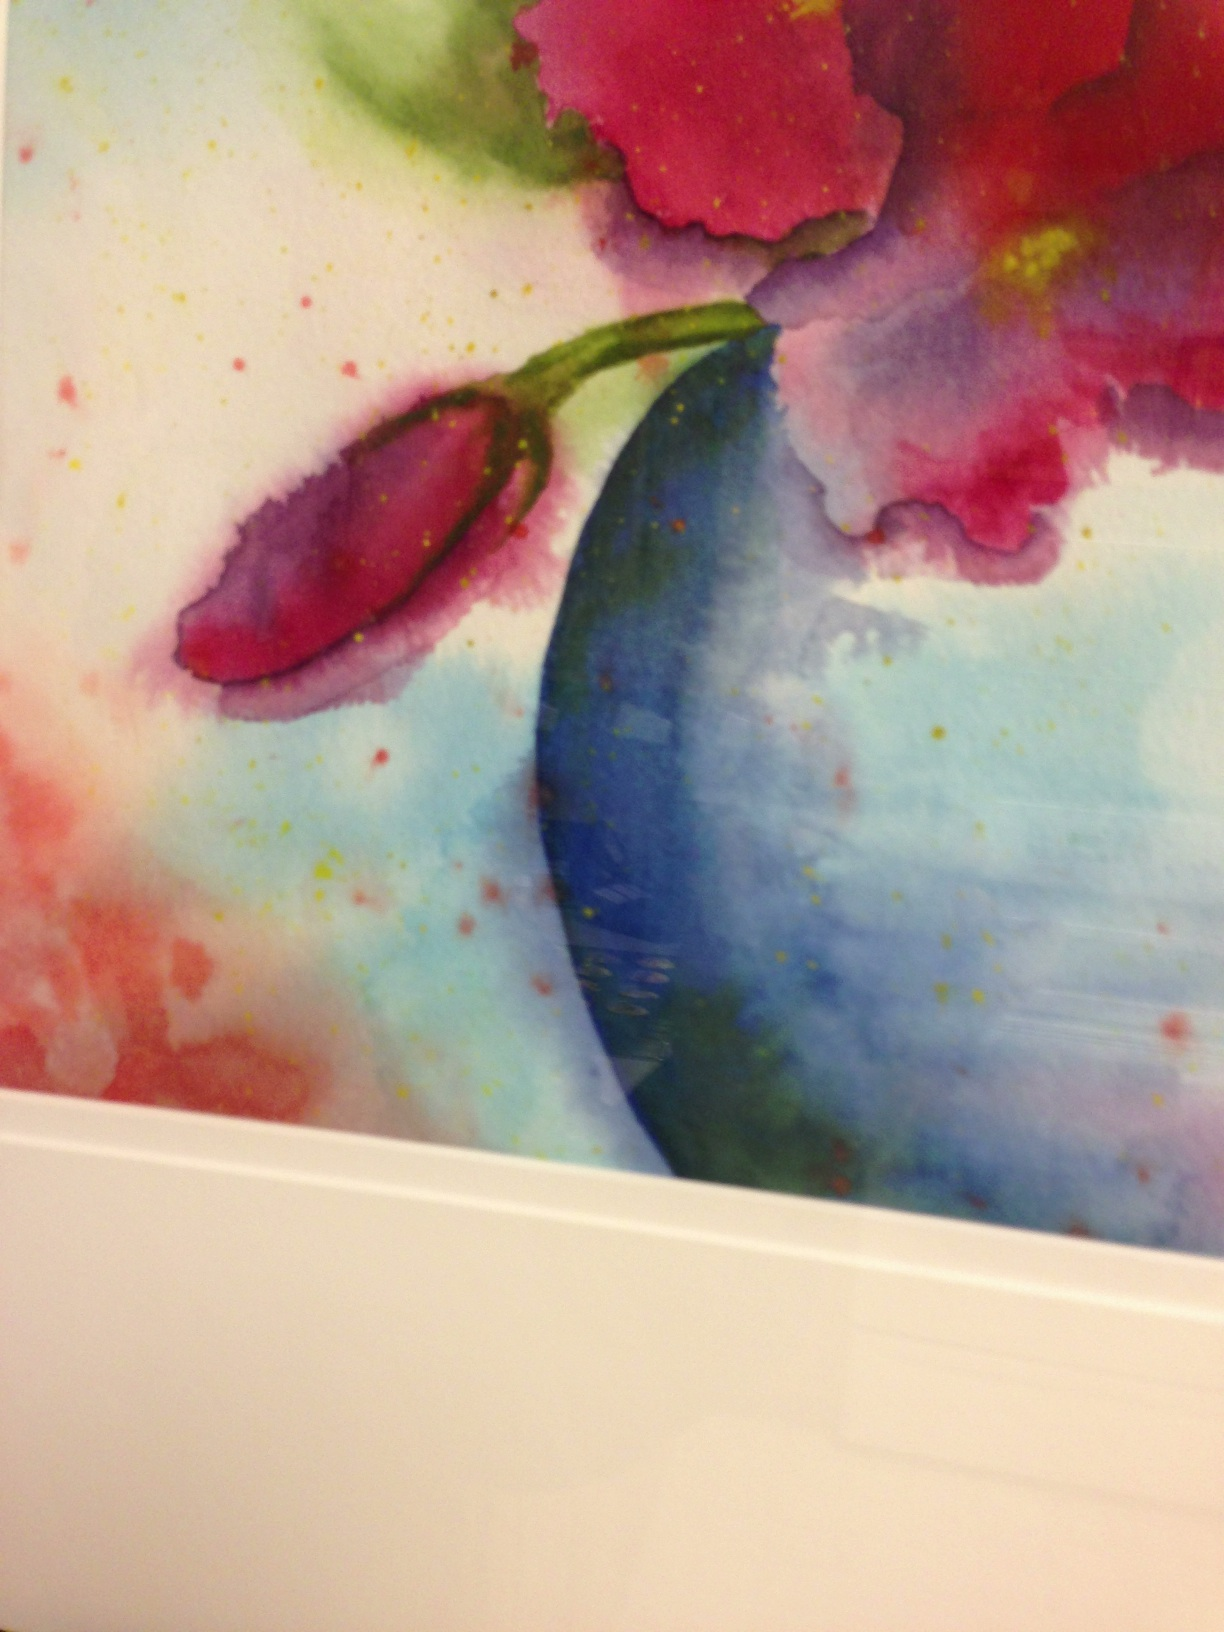What emotions or ideas might the artist be expressing through the use of such vibrant and erratic colors in this flower painting? The use of vibrant and intense colors in the flower painting could be reflecting feelings of passion and vitality, or possibly the chaotic beauty of nature. The chaotic splash of colors might also suggest a sense of freedom or rebirth associated with spring. 